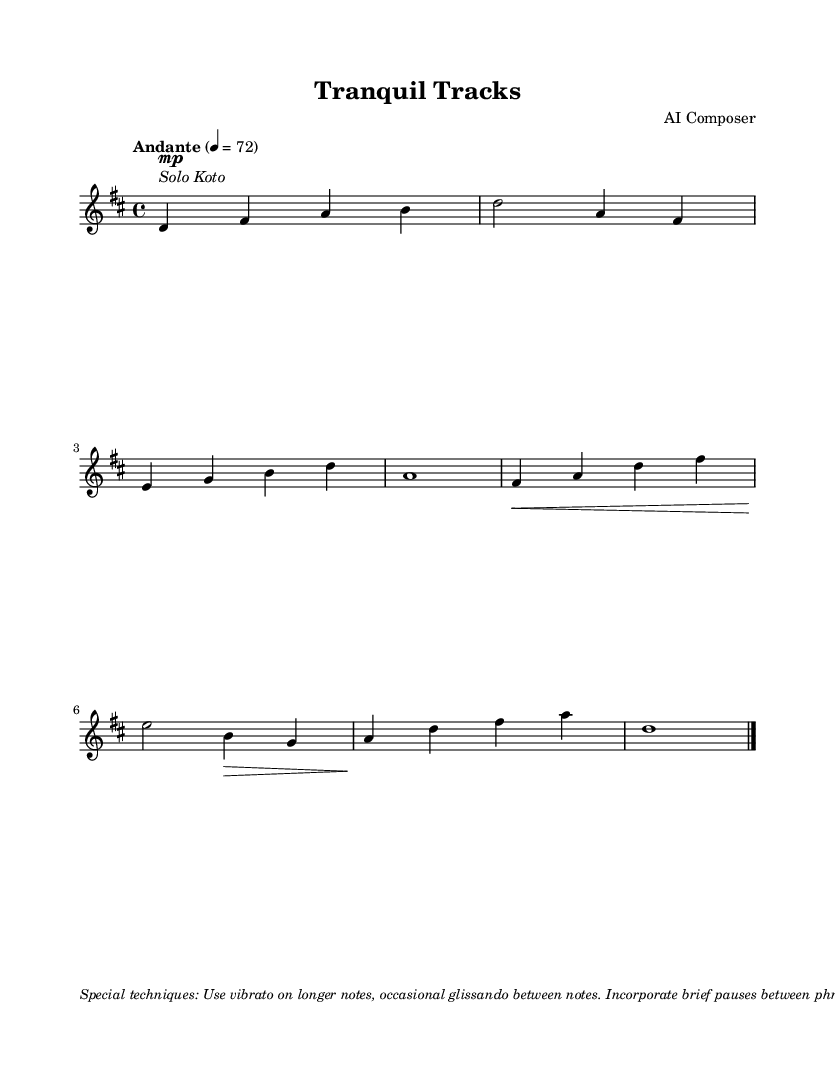What is the key signature of this music? The key signature is indicated at the beginning of the music by the sharp signs on the staff. In this case, there are two sharps, which corresponds to D major.
Answer: D major What is the time signature of this piece? The time signature appears at the beginning of the staff and is represented as a fraction. Here, it shows 4/4, meaning there are four beats in a measure and the quarter note gets one beat.
Answer: 4/4 What is the tempo marking for this composition? The tempo marking is located at the start of the score and is given as "Andante," which suggests a moderate pace. A numeric marking of 4 = 72 indicates the beats per minute.
Answer: Andante How many measures are there in this music? To count the measures, we look for bar lines that separate each measure. By counting each segment between the bar lines, we find that there are eight measures in total.
Answer: Eight What special techniques are mentioned for the performance of this piece? The techniques are listed in the markup section at the end of the score. They specify the use of vibrato, glissando, pauses, and describe the desired rhythm and note articulation.
Answer: Vibrato, glissando, pauses How does the dynamic marking in the first measure affect the performance? The dynamic marking in the first measure indicates "mp," meaning moderately soft. This instructs the performer to play quietly, setting a tranquil mood which is essential for evoking tranquility.
Answer: Moderately soft 